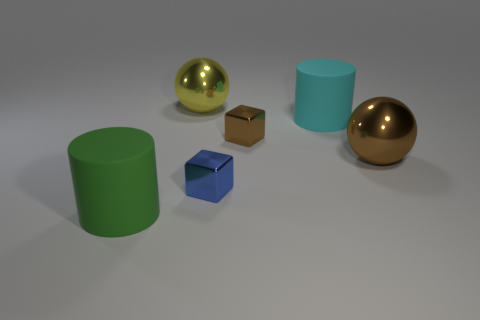What is the color of the shiny ball that is in front of the metallic ball to the left of the cyan object?
Offer a terse response. Brown. How big is the brown metallic object behind the ball in front of the large yellow metallic sphere that is behind the cyan matte thing?
Your answer should be very brief. Small. Do the yellow object and the blue thing that is on the left side of the cyan matte object have the same material?
Give a very brief answer. Yes. What is the size of the blue block that is the same material as the large yellow ball?
Your answer should be very brief. Small. Are there any other large matte things that have the same shape as the green matte object?
Provide a short and direct response. Yes. What number of things are either big cylinders behind the large green thing or shiny blocks?
Give a very brief answer. 3. Do the tiny object behind the large brown thing and the metal sphere that is to the right of the large yellow sphere have the same color?
Make the answer very short. Yes. What is the size of the cyan rubber thing?
Ensure brevity in your answer.  Large. How many tiny things are yellow metallic things or brown metal things?
Make the answer very short. 1. There is a cylinder that is the same size as the green object; what color is it?
Give a very brief answer. Cyan. 